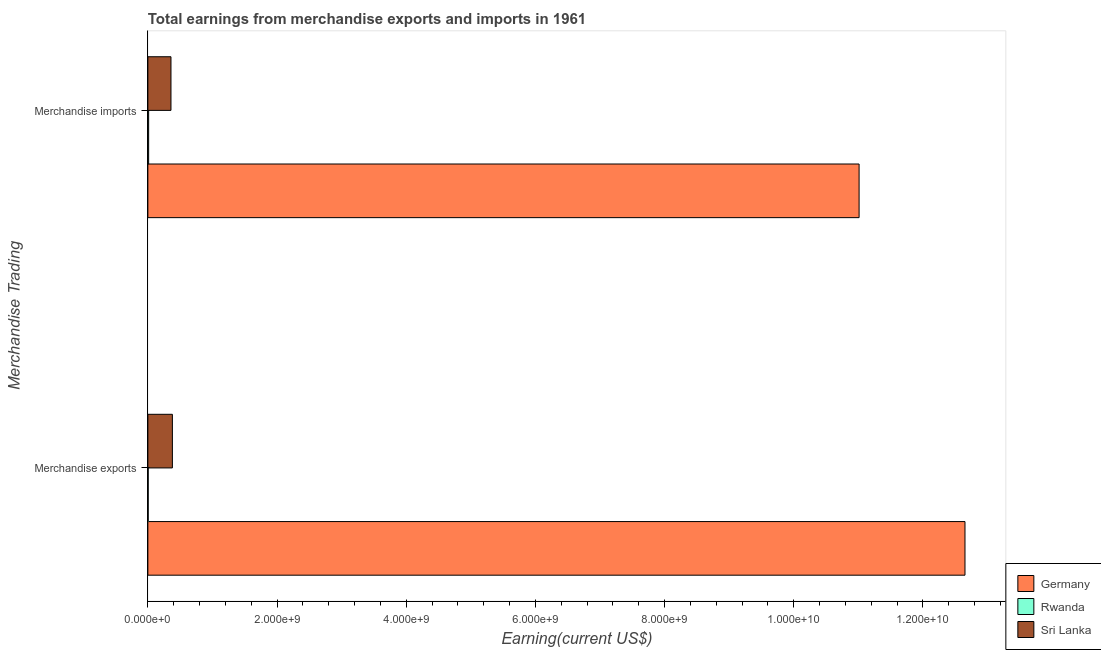Are the number of bars per tick equal to the number of legend labels?
Offer a terse response. Yes. Are the number of bars on each tick of the Y-axis equal?
Offer a terse response. Yes. What is the earnings from merchandise exports in Rwanda?
Make the answer very short. 5.00e+06. Across all countries, what is the maximum earnings from merchandise exports?
Make the answer very short. 1.27e+1. Across all countries, what is the minimum earnings from merchandise imports?
Ensure brevity in your answer.  1.20e+07. In which country was the earnings from merchandise exports minimum?
Provide a short and direct response. Rwanda. What is the total earnings from merchandise imports in the graph?
Provide a short and direct response. 1.14e+1. What is the difference between the earnings from merchandise exports in Sri Lanka and that in Rwanda?
Keep it short and to the point. 3.75e+08. What is the difference between the earnings from merchandise imports in Rwanda and the earnings from merchandise exports in Sri Lanka?
Give a very brief answer. -3.68e+08. What is the average earnings from merchandise imports per country?
Give a very brief answer. 3.79e+09. What is the difference between the earnings from merchandise exports and earnings from merchandise imports in Sri Lanka?
Make the answer very short. 2.20e+07. What is the ratio of the earnings from merchandise imports in Rwanda to that in Germany?
Offer a terse response. 0. Is the earnings from merchandise exports in Sri Lanka less than that in Rwanda?
Keep it short and to the point. No. In how many countries, is the earnings from merchandise imports greater than the average earnings from merchandise imports taken over all countries?
Give a very brief answer. 1. What does the 2nd bar from the top in Merchandise exports represents?
Offer a terse response. Rwanda. How many bars are there?
Offer a terse response. 6. What is the difference between two consecutive major ticks on the X-axis?
Make the answer very short. 2.00e+09. Does the graph contain any zero values?
Your answer should be compact. No. Does the graph contain grids?
Your response must be concise. No. How many legend labels are there?
Provide a short and direct response. 3. How are the legend labels stacked?
Your answer should be very brief. Vertical. What is the title of the graph?
Offer a very short reply. Total earnings from merchandise exports and imports in 1961. What is the label or title of the X-axis?
Give a very brief answer. Earning(current US$). What is the label or title of the Y-axis?
Keep it short and to the point. Merchandise Trading. What is the Earning(current US$) in Germany in Merchandise exports?
Provide a succinct answer. 1.27e+1. What is the Earning(current US$) of Rwanda in Merchandise exports?
Provide a short and direct response. 5.00e+06. What is the Earning(current US$) of Sri Lanka in Merchandise exports?
Your response must be concise. 3.80e+08. What is the Earning(current US$) in Germany in Merchandise imports?
Offer a terse response. 1.10e+1. What is the Earning(current US$) in Sri Lanka in Merchandise imports?
Provide a succinct answer. 3.58e+08. Across all Merchandise Trading, what is the maximum Earning(current US$) in Germany?
Your answer should be very brief. 1.27e+1. Across all Merchandise Trading, what is the maximum Earning(current US$) of Rwanda?
Offer a very short reply. 1.20e+07. Across all Merchandise Trading, what is the maximum Earning(current US$) of Sri Lanka?
Provide a short and direct response. 3.80e+08. Across all Merchandise Trading, what is the minimum Earning(current US$) of Germany?
Keep it short and to the point. 1.10e+1. Across all Merchandise Trading, what is the minimum Earning(current US$) of Rwanda?
Offer a very short reply. 5.00e+06. Across all Merchandise Trading, what is the minimum Earning(current US$) in Sri Lanka?
Make the answer very short. 3.58e+08. What is the total Earning(current US$) of Germany in the graph?
Make the answer very short. 2.37e+1. What is the total Earning(current US$) in Rwanda in the graph?
Ensure brevity in your answer.  1.70e+07. What is the total Earning(current US$) in Sri Lanka in the graph?
Keep it short and to the point. 7.37e+08. What is the difference between the Earning(current US$) of Germany in Merchandise exports and that in Merchandise imports?
Your response must be concise. 1.64e+09. What is the difference between the Earning(current US$) of Rwanda in Merchandise exports and that in Merchandise imports?
Offer a terse response. -7.00e+06. What is the difference between the Earning(current US$) of Sri Lanka in Merchandise exports and that in Merchandise imports?
Provide a short and direct response. 2.20e+07. What is the difference between the Earning(current US$) of Germany in Merchandise exports and the Earning(current US$) of Rwanda in Merchandise imports?
Your answer should be compact. 1.26e+1. What is the difference between the Earning(current US$) of Germany in Merchandise exports and the Earning(current US$) of Sri Lanka in Merchandise imports?
Provide a succinct answer. 1.23e+1. What is the difference between the Earning(current US$) of Rwanda in Merchandise exports and the Earning(current US$) of Sri Lanka in Merchandise imports?
Ensure brevity in your answer.  -3.53e+08. What is the average Earning(current US$) of Germany per Merchandise Trading?
Give a very brief answer. 1.18e+1. What is the average Earning(current US$) in Rwanda per Merchandise Trading?
Give a very brief answer. 8.50e+06. What is the average Earning(current US$) of Sri Lanka per Merchandise Trading?
Your response must be concise. 3.69e+08. What is the difference between the Earning(current US$) in Germany and Earning(current US$) in Rwanda in Merchandise exports?
Ensure brevity in your answer.  1.26e+1. What is the difference between the Earning(current US$) of Germany and Earning(current US$) of Sri Lanka in Merchandise exports?
Keep it short and to the point. 1.23e+1. What is the difference between the Earning(current US$) in Rwanda and Earning(current US$) in Sri Lanka in Merchandise exports?
Your answer should be very brief. -3.75e+08. What is the difference between the Earning(current US$) of Germany and Earning(current US$) of Rwanda in Merchandise imports?
Offer a very short reply. 1.10e+1. What is the difference between the Earning(current US$) of Germany and Earning(current US$) of Sri Lanka in Merchandise imports?
Make the answer very short. 1.07e+1. What is the difference between the Earning(current US$) in Rwanda and Earning(current US$) in Sri Lanka in Merchandise imports?
Make the answer very short. -3.46e+08. What is the ratio of the Earning(current US$) in Germany in Merchandise exports to that in Merchandise imports?
Provide a succinct answer. 1.15. What is the ratio of the Earning(current US$) of Rwanda in Merchandise exports to that in Merchandise imports?
Provide a short and direct response. 0.42. What is the ratio of the Earning(current US$) in Sri Lanka in Merchandise exports to that in Merchandise imports?
Offer a terse response. 1.06. What is the difference between the highest and the second highest Earning(current US$) in Germany?
Make the answer very short. 1.64e+09. What is the difference between the highest and the second highest Earning(current US$) of Rwanda?
Your answer should be very brief. 7.00e+06. What is the difference between the highest and the second highest Earning(current US$) of Sri Lanka?
Offer a very short reply. 2.20e+07. What is the difference between the highest and the lowest Earning(current US$) of Germany?
Make the answer very short. 1.64e+09. What is the difference between the highest and the lowest Earning(current US$) of Sri Lanka?
Provide a short and direct response. 2.20e+07. 